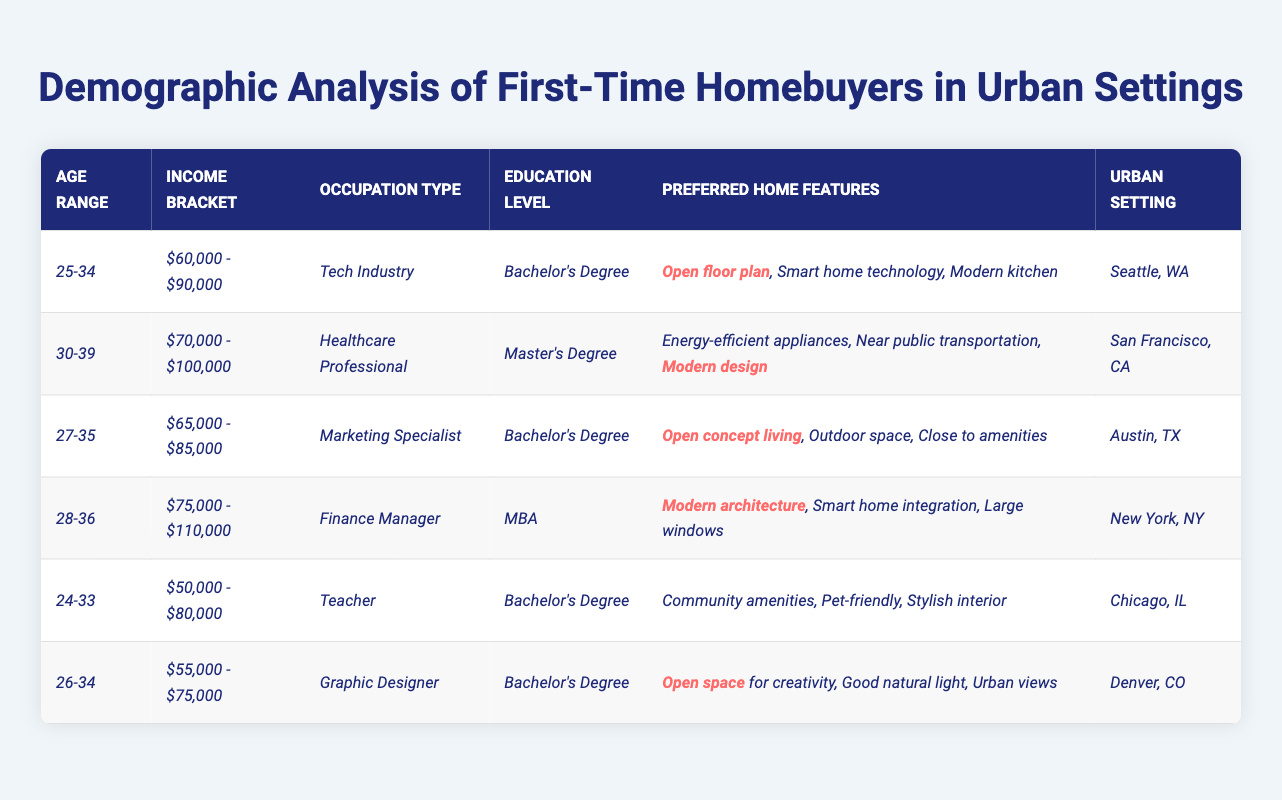What is the income bracket of first-time homebuyers in Seattle? Referring to the table, under the urban setting "Seattle, WA," the income bracket listed is "$60,000 - $90,000."
Answer: $60,000 - $90,000 Which home feature is highlighted for the Marketing Specialist? The row for the Marketing Specialist indicates the preferred home features, and "Open concept living" is highlighted as a key feature.
Answer: Open concept living What is the highest income bracket among the listed urban settings? By examining the income brackets in the table, the highest listed is "$75,000 - $110,000," which corresponds to the Finance Manager in New York.
Answer: $75,000 - $110,000 Is there a first-time homebuyer group with a preference for energy-efficient appliances? The table mentions a Healthcare Professional in San Francisco, who prefers energy-efficient appliances among other features. This confirms the presence of such a preference.
Answer: Yes What is the average income bracket of first-time homebuyers who have a Bachelor's degree? The income brackets for those with a Bachelor's degree are $60,000 - $90,000, $65,000 - $85,000, $50,000 - $80,000, and $55,000 - $75,000. Estimating the average involves simplifying these ranges: (75,000 + 67,500 + 65,000 + 62,500) / 4 = 67,500.
Answer: $67,500 In which urban setting is "Modern architecture" a preferred home feature? The characteristic "Modern architecture" appears in the row for the Finance Manager, who is situated in New York, indicating that this feature is desired in that urban setting.
Answer: New York, NY How many first-time homebuyers have a preference for an open floor plan? The table lists two specific instances: one for the Tech Industry in Seattle and another for the Marketing Specialist in Austin, indicating a total of two groups with this preference.
Answer: 2 What percentage of first-time homebuyers prefer smart home technology? Out of the six homebuyer profiles, only one (the Tech Industry in Seattle) explicitly mentions "Smart home technology" as a preferred feature, which accounts for approximately 16.67% of the groups. This is derived from the calculation (1/6)*100.
Answer: 16.67% What is the age range for first-time homebuyers with modern designs as a preference? Looking at the data, the first-time homebuyer who wants "Modern design" falls in the age range of 30-39, according to the Healthcare Professional in San Francisco.
Answer: 30-39 Which occupation type is associated with pet-friendly home features? The table shows that a Teacher, listed under the age range 24-33 in Chicago, prefers pet-friendly home features among other amenities.
Answer: Teacher 